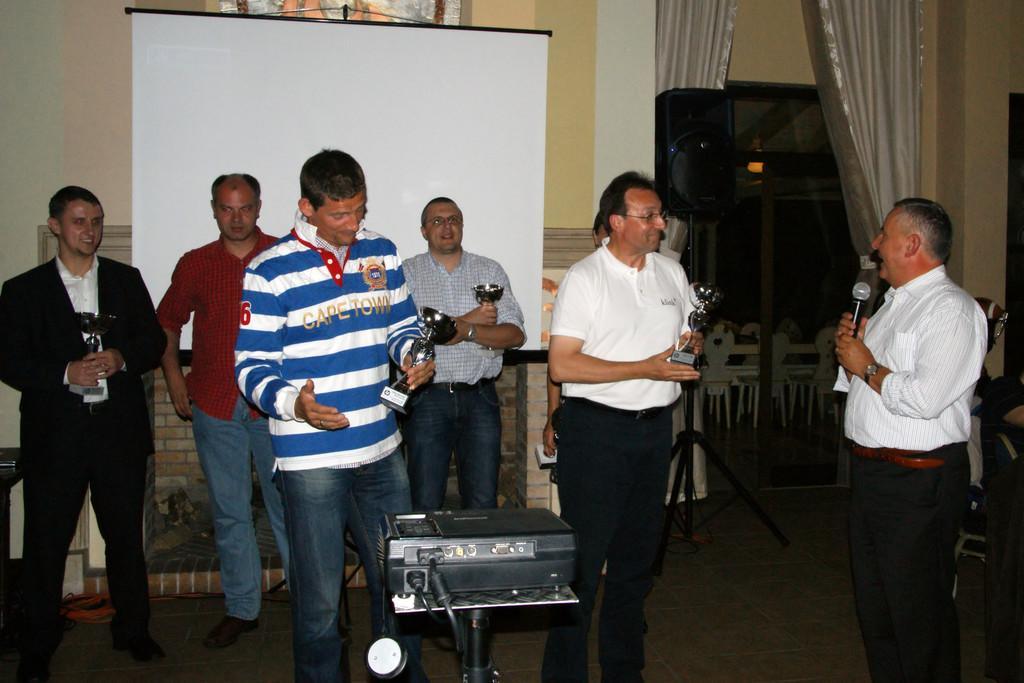Please provide a concise description of this image. In this image, I can see a group of people standing. On the right side of the image, I can see an object and a man holding a mike. Behind the people, I can see a projector screen and a speaker with a stand. I can see the chairs through a glass door and there are curtains. In the background, I can see a fireplace. 